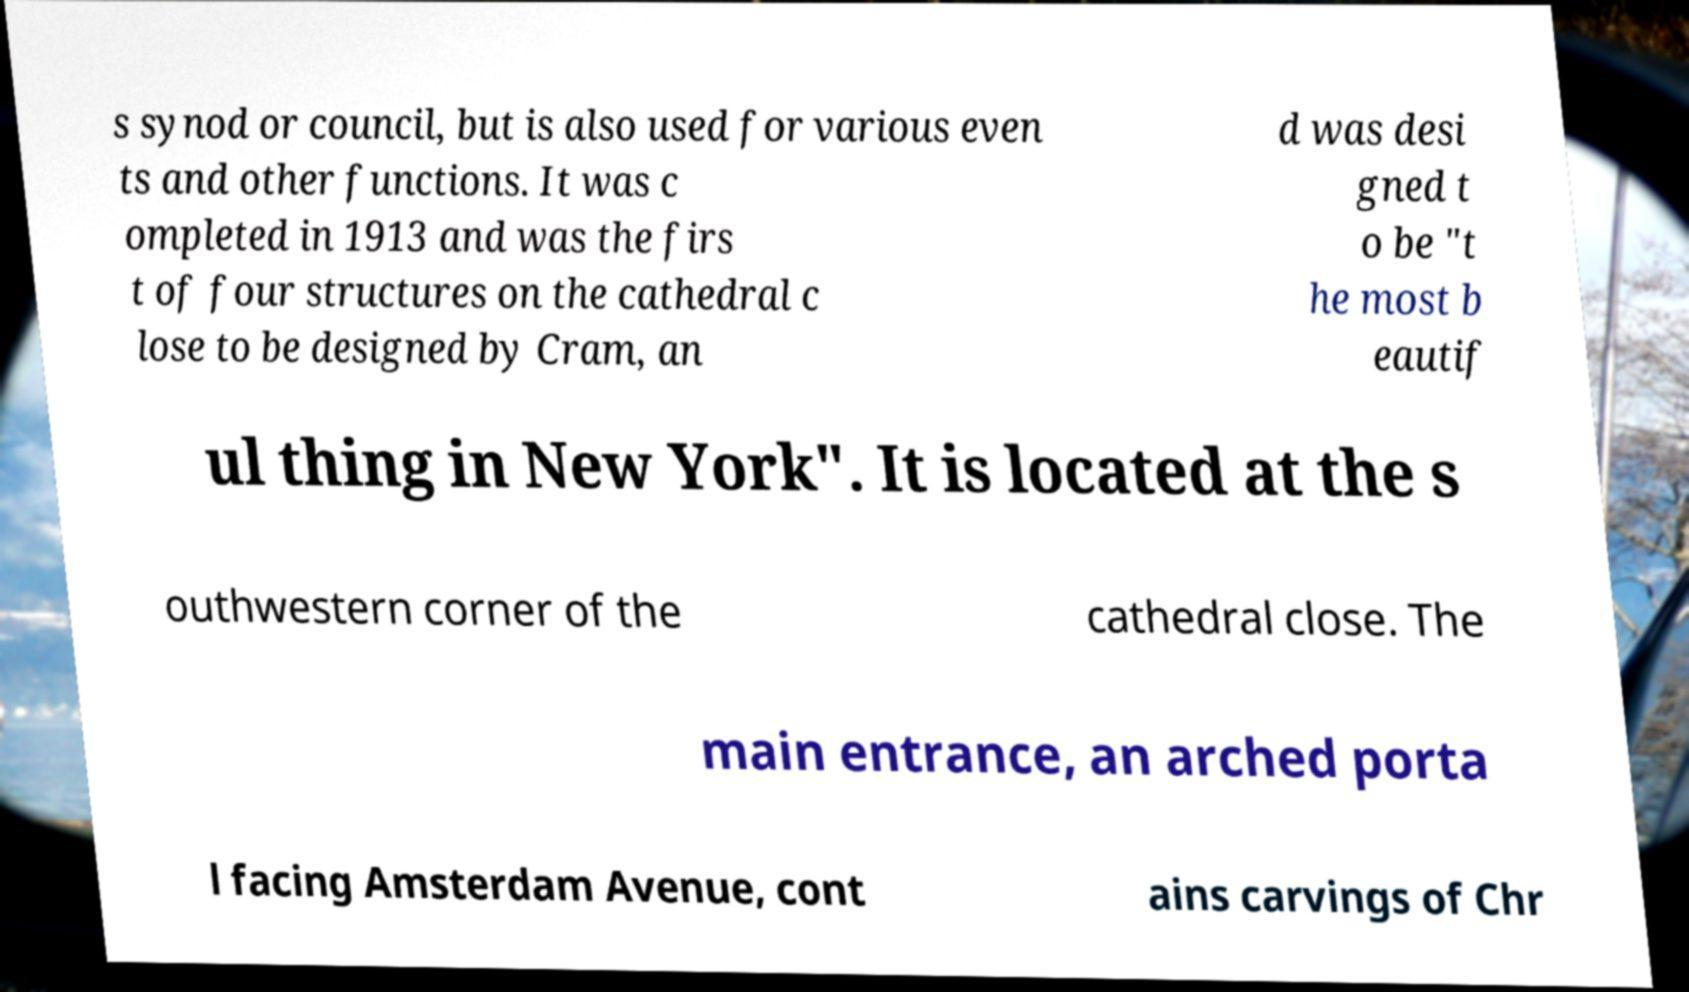Could you extract and type out the text from this image? s synod or council, but is also used for various even ts and other functions. It was c ompleted in 1913 and was the firs t of four structures on the cathedral c lose to be designed by Cram, an d was desi gned t o be "t he most b eautif ul thing in New York". It is located at the s outhwestern corner of the cathedral close. The main entrance, an arched porta l facing Amsterdam Avenue, cont ains carvings of Chr 